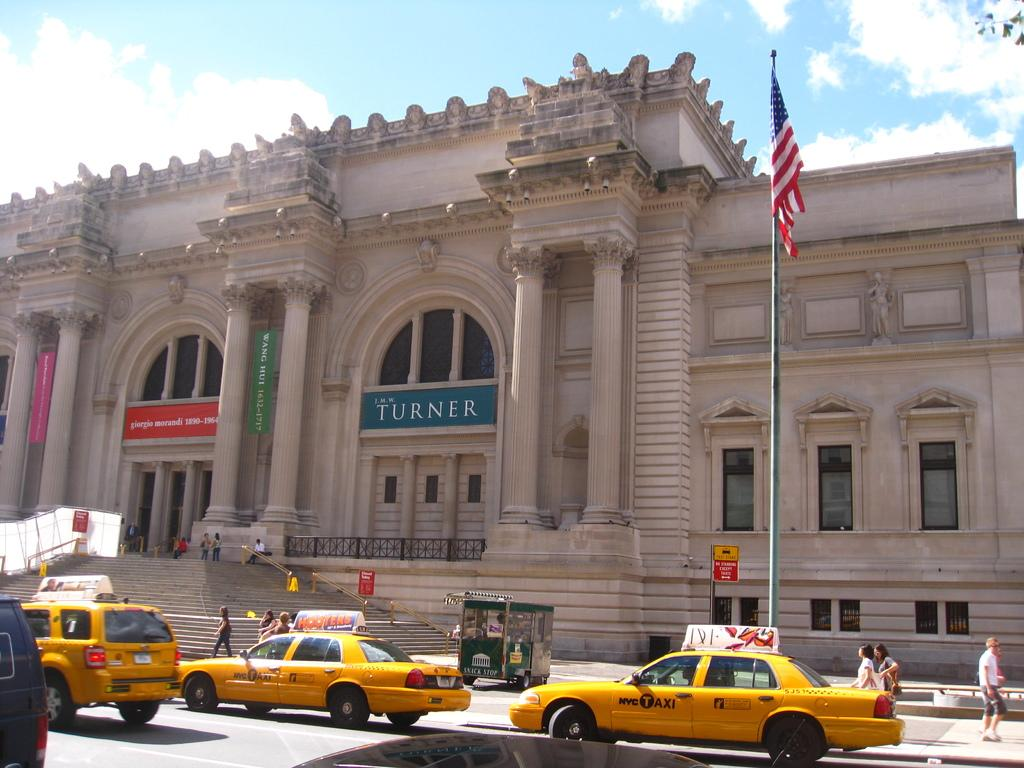Provide a one-sentence caption for the provided image. lots of taxi cabs on the street and people on the sidewalk. 